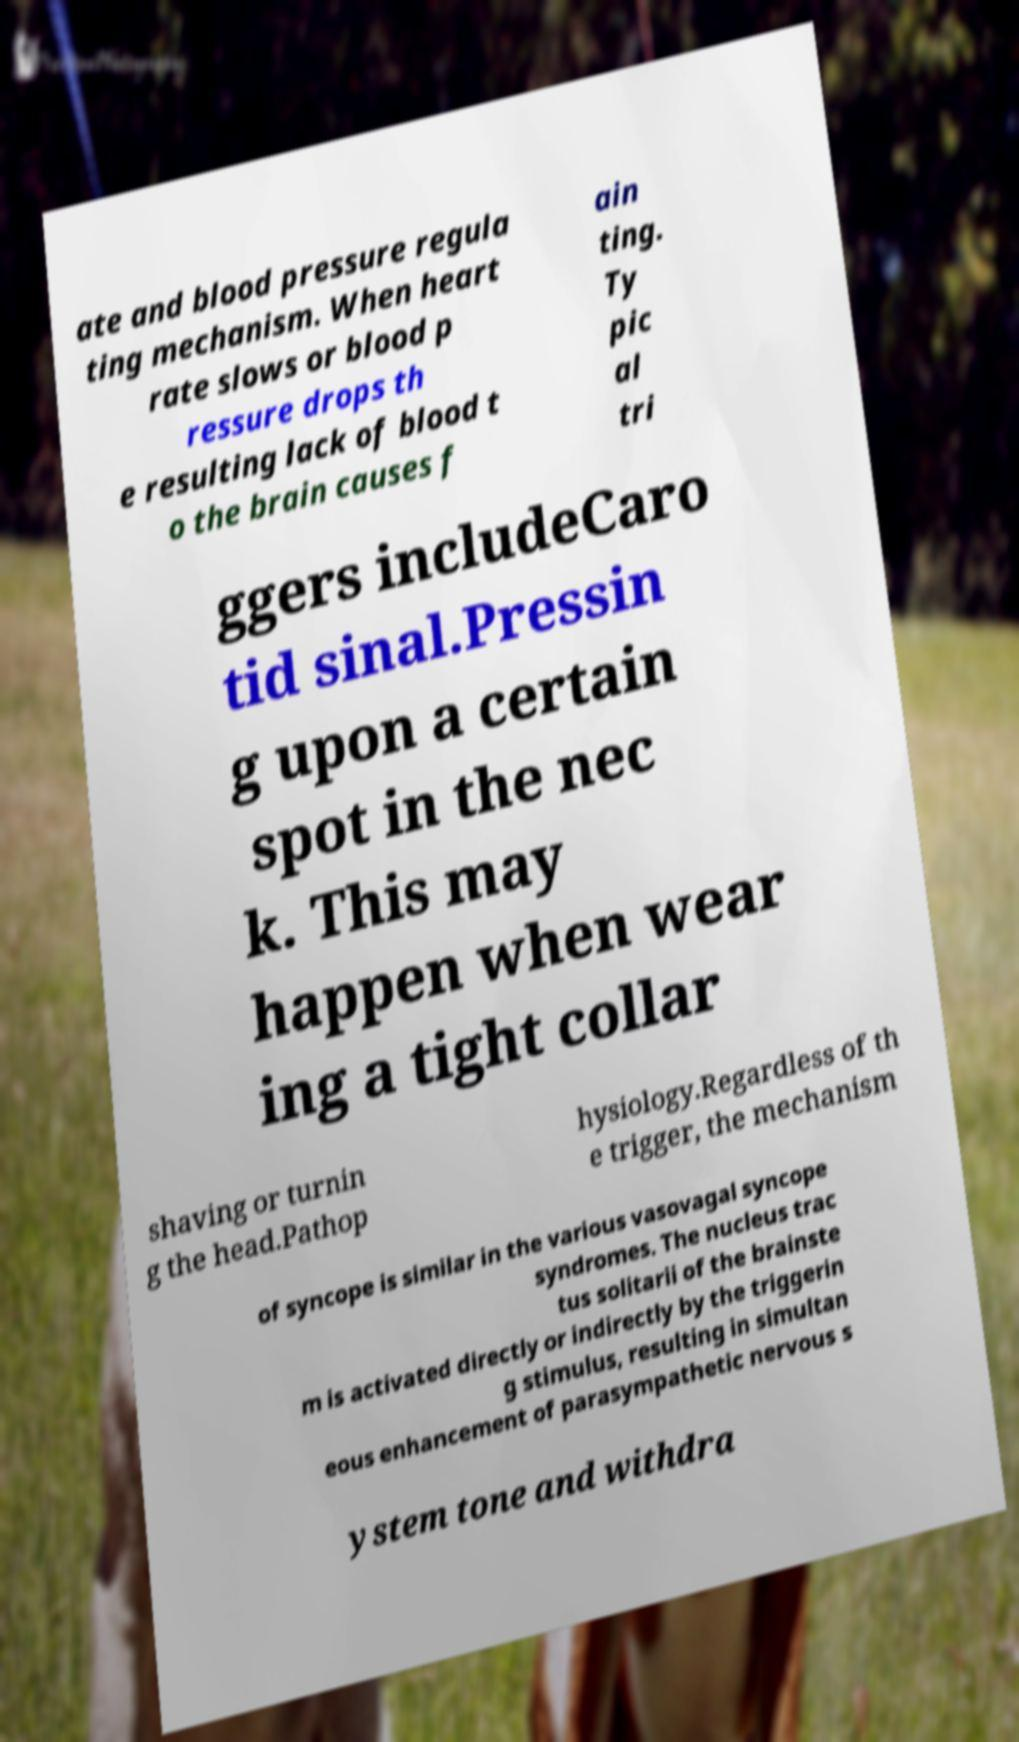I need the written content from this picture converted into text. Can you do that? ate and blood pressure regula ting mechanism. When heart rate slows or blood p ressure drops th e resulting lack of blood t o the brain causes f ain ting. Ty pic al tri ggers includeCaro tid sinal.Pressin g upon a certain spot in the nec k. This may happen when wear ing a tight collar shaving or turnin g the head.Pathop hysiology.Regardless of th e trigger, the mechanism of syncope is similar in the various vasovagal syncope syndromes. The nucleus trac tus solitarii of the brainste m is activated directly or indirectly by the triggerin g stimulus, resulting in simultan eous enhancement of parasympathetic nervous s ystem tone and withdra 